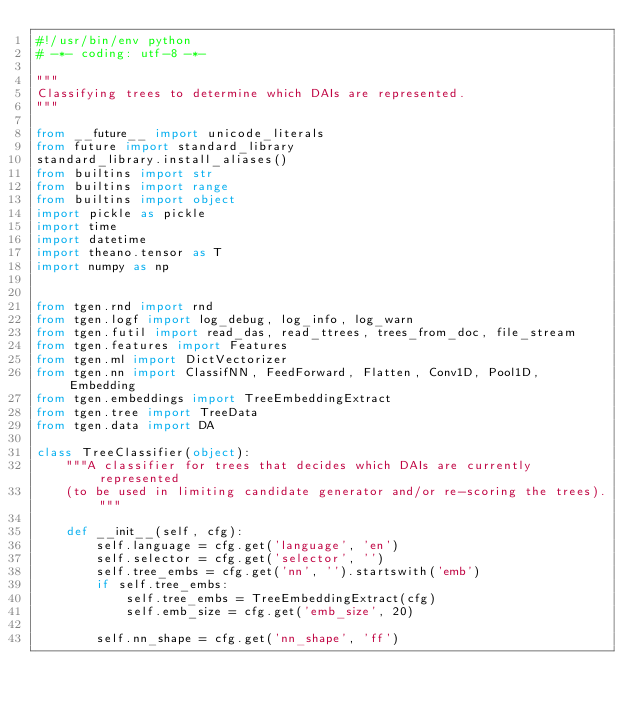<code> <loc_0><loc_0><loc_500><loc_500><_Python_>#!/usr/bin/env python
# -*- coding: utf-8 -*-

"""
Classifying trees to determine which DAIs are represented.
"""

from __future__ import unicode_literals
from future import standard_library
standard_library.install_aliases()
from builtins import str
from builtins import range
from builtins import object
import pickle as pickle
import time
import datetime
import theano.tensor as T
import numpy as np


from tgen.rnd import rnd
from tgen.logf import log_debug, log_info, log_warn
from tgen.futil import read_das, read_ttrees, trees_from_doc, file_stream
from tgen.features import Features
from tgen.ml import DictVectorizer
from tgen.nn import ClassifNN, FeedForward, Flatten, Conv1D, Pool1D, Embedding
from tgen.embeddings import TreeEmbeddingExtract
from tgen.tree import TreeData
from tgen.data import DA

class TreeClassifier(object):
    """A classifier for trees that decides which DAIs are currently represented
    (to be used in limiting candidate generator and/or re-scoring the trees)."""

    def __init__(self, cfg):
        self.language = cfg.get('language', 'en')
        self.selector = cfg.get('selector', '')
        self.tree_embs = cfg.get('nn', '').startswith('emb')
        if self.tree_embs:
            self.tree_embs = TreeEmbeddingExtract(cfg)
            self.emb_size = cfg.get('emb_size', 20)

        self.nn_shape = cfg.get('nn_shape', 'ff')</code> 